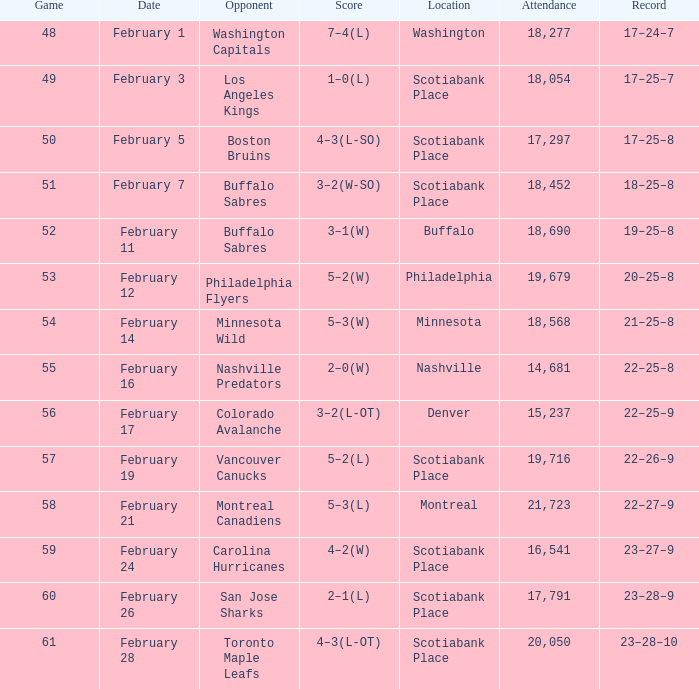What typical match took place on february 24 and had a turnout less than 16,541? None. 